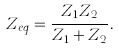Convert formula to latex. <formula><loc_0><loc_0><loc_500><loc_500>Z _ { e q } = { \frac { Z _ { 1 } Z _ { 2 } } { Z _ { 1 } + Z _ { 2 } } } .</formula> 